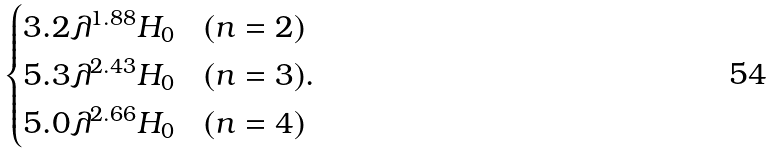<formula> <loc_0><loc_0><loc_500><loc_500>\begin{cases} 3 . 2 \lambda ^ { 1 . 8 8 } H _ { 0 } & ( n = 2 ) \\ 5 . 3 \lambda ^ { 2 . 4 3 } H _ { 0 } & ( n = 3 ) . \\ 5 . 0 \lambda ^ { 2 . 6 6 } H _ { 0 } & ( n = 4 ) \end{cases}</formula> 